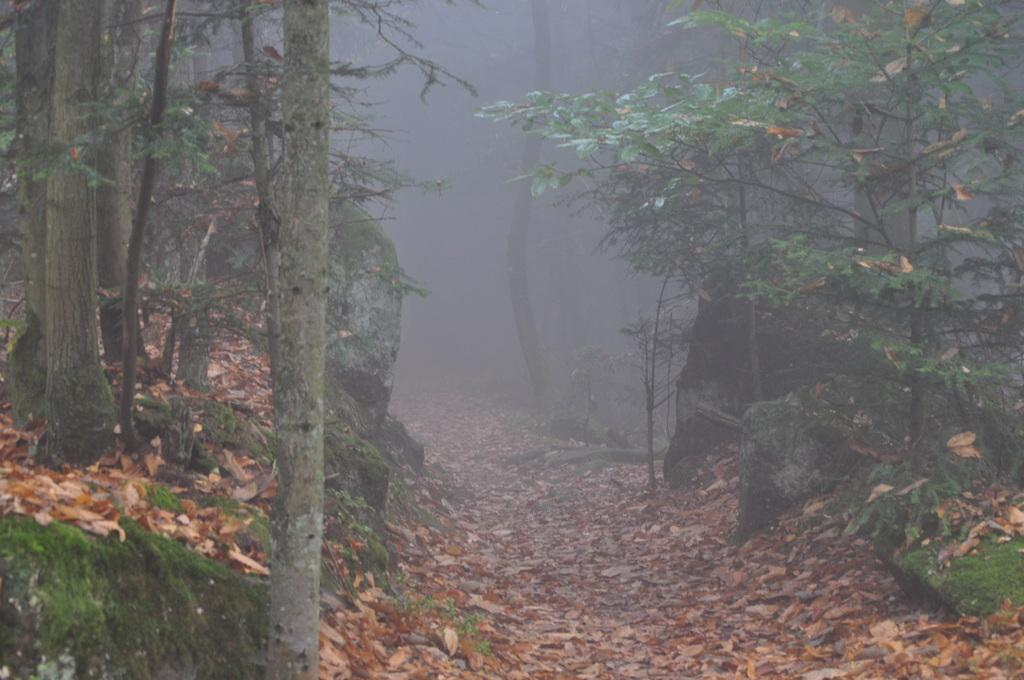What is the main feature in the middle of the image? There is a path in the middle of the image. How are the dry leaves distributed on the path? The path is covered with dry leaves. What type of vegetation is present on either side of the path? Trees are present on either side of the path. What is the price of the soap on the path in the image? There is no soap present in the image, so it is not possible to determine its price. 